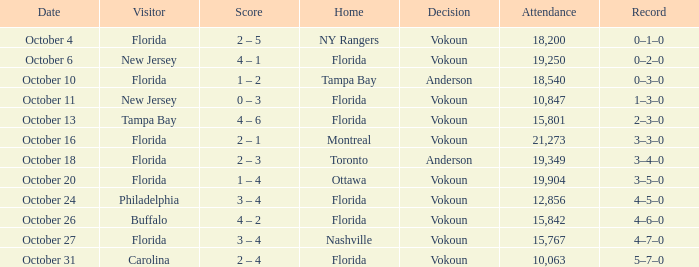Which team was home on October 13? Florida. 